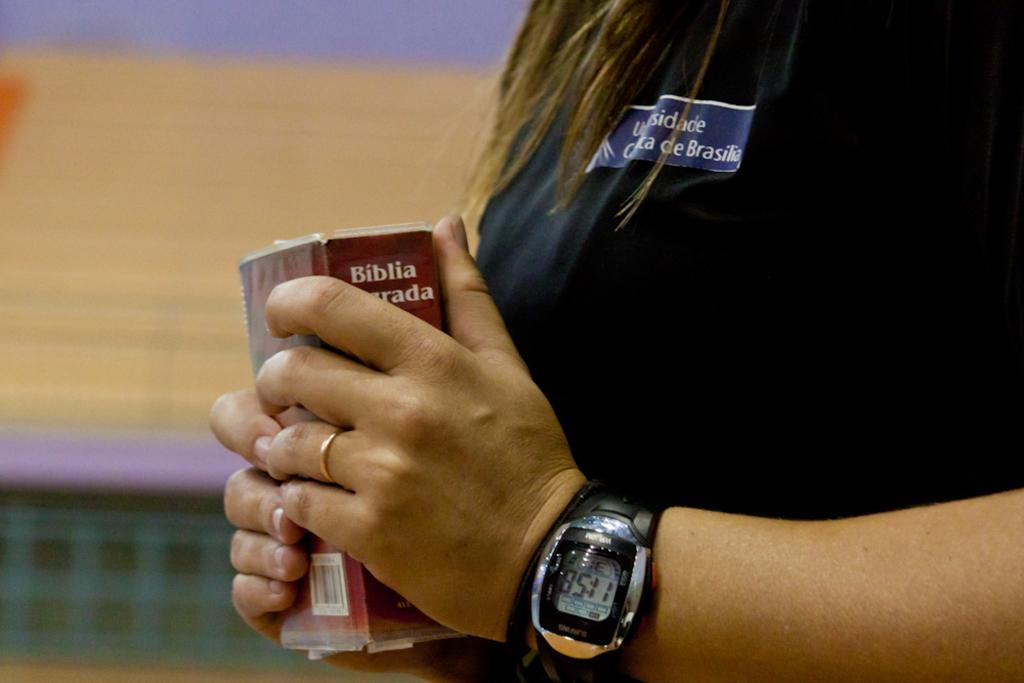Which book is it?
Make the answer very short. Biblia. 